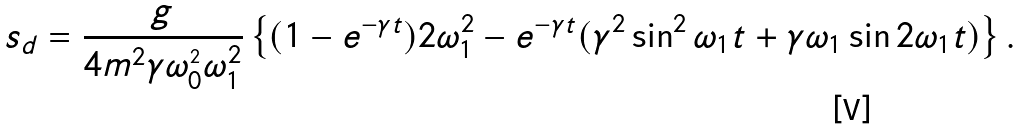Convert formula to latex. <formula><loc_0><loc_0><loc_500><loc_500>s _ { d } = \frac { g } { 4 m ^ { 2 } \gamma \omega ^ { _ { 2 } } _ { 0 } \omega ^ { 2 } _ { 1 } } \left \{ ( 1 - e ^ { - \gamma t } ) 2 \omega ^ { 2 } _ { 1 } - e ^ { - \gamma t } ( \gamma ^ { 2 } \sin ^ { 2 } \omega _ { 1 } t + \gamma \omega _ { 1 } \sin 2 \omega _ { 1 } t ) \right \} .</formula> 